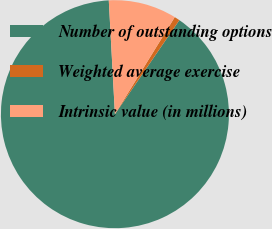<chart> <loc_0><loc_0><loc_500><loc_500><pie_chart><fcel>Number of outstanding options<fcel>Weighted average exercise<fcel>Intrinsic value (in millions)<nl><fcel>89.58%<fcel>0.77%<fcel>9.65%<nl></chart> 